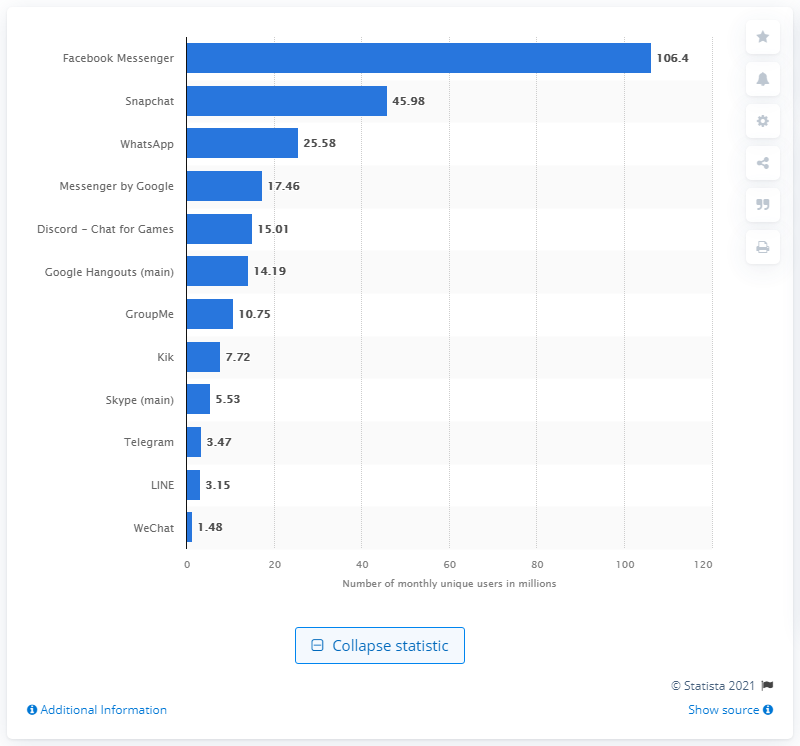Mention a couple of crucial points in this snapshot. Snapchat had approximately 45.98 unique users in September 2019. As of September 2019, Facebook Messenger was the most popular mobile messenger app in the United States. In September 2019, Facebook Messenger had a total of 106.4 unique users. 